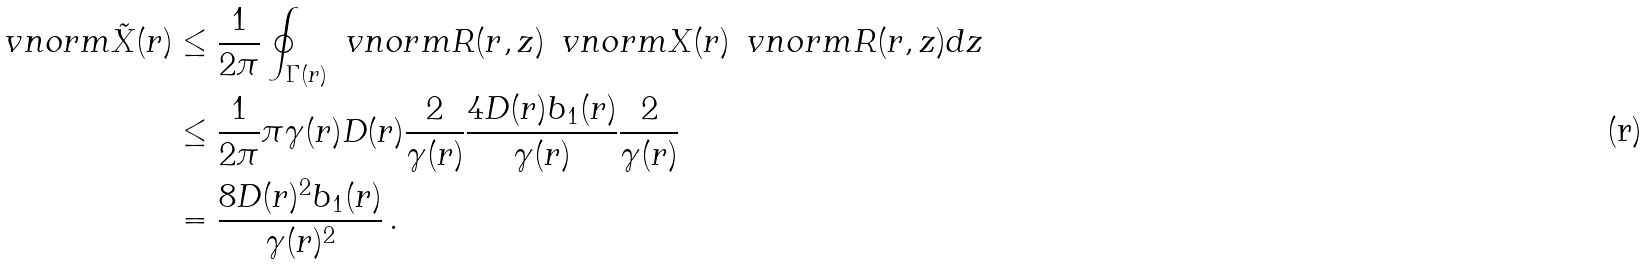<formula> <loc_0><loc_0><loc_500><loc_500>\ v n o r m { \tilde { X } ( r ) } & \leq \frac { 1 } { 2 \pi } \oint _ { \Gamma ( r ) } \ v n o r m { R ( r , z ) } \, \ v n o r m { X ( r ) } \, \ v n o r m { R ( r , z ) } d z \\ & \leq \frac { 1 } { 2 \pi } \pi \gamma ( r ) D ( r ) \frac { 2 } { \gamma ( r ) } \frac { 4 D ( r ) b _ { 1 } ( r ) } { \gamma ( r ) } \frac { 2 } { \gamma ( r ) } \\ & = \frac { 8 D ( r ) ^ { 2 } b _ { 1 } ( r ) } { \gamma ( r ) ^ { 2 } } \, .</formula> 